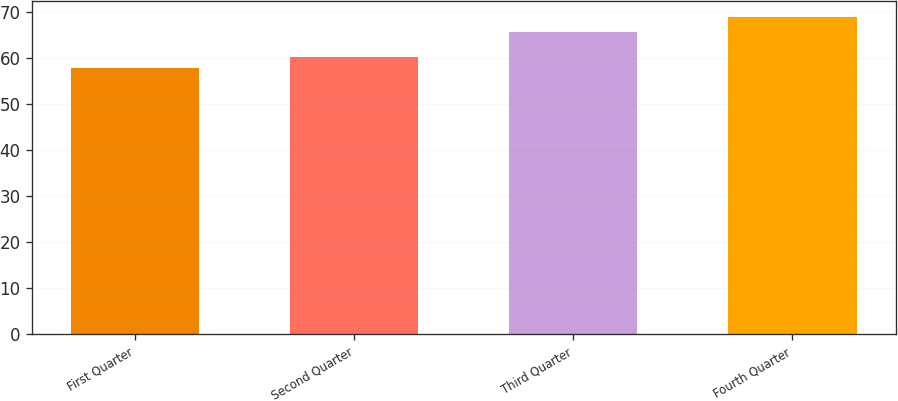Convert chart to OTSL. <chart><loc_0><loc_0><loc_500><loc_500><bar_chart><fcel>First Quarter<fcel>Second Quarter<fcel>Third Quarter<fcel>Fourth Quarter<nl><fcel>57.82<fcel>60.11<fcel>65.68<fcel>68.83<nl></chart> 